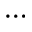Convert formula to latex. <formula><loc_0><loc_0><loc_500><loc_500>\cdots</formula> 